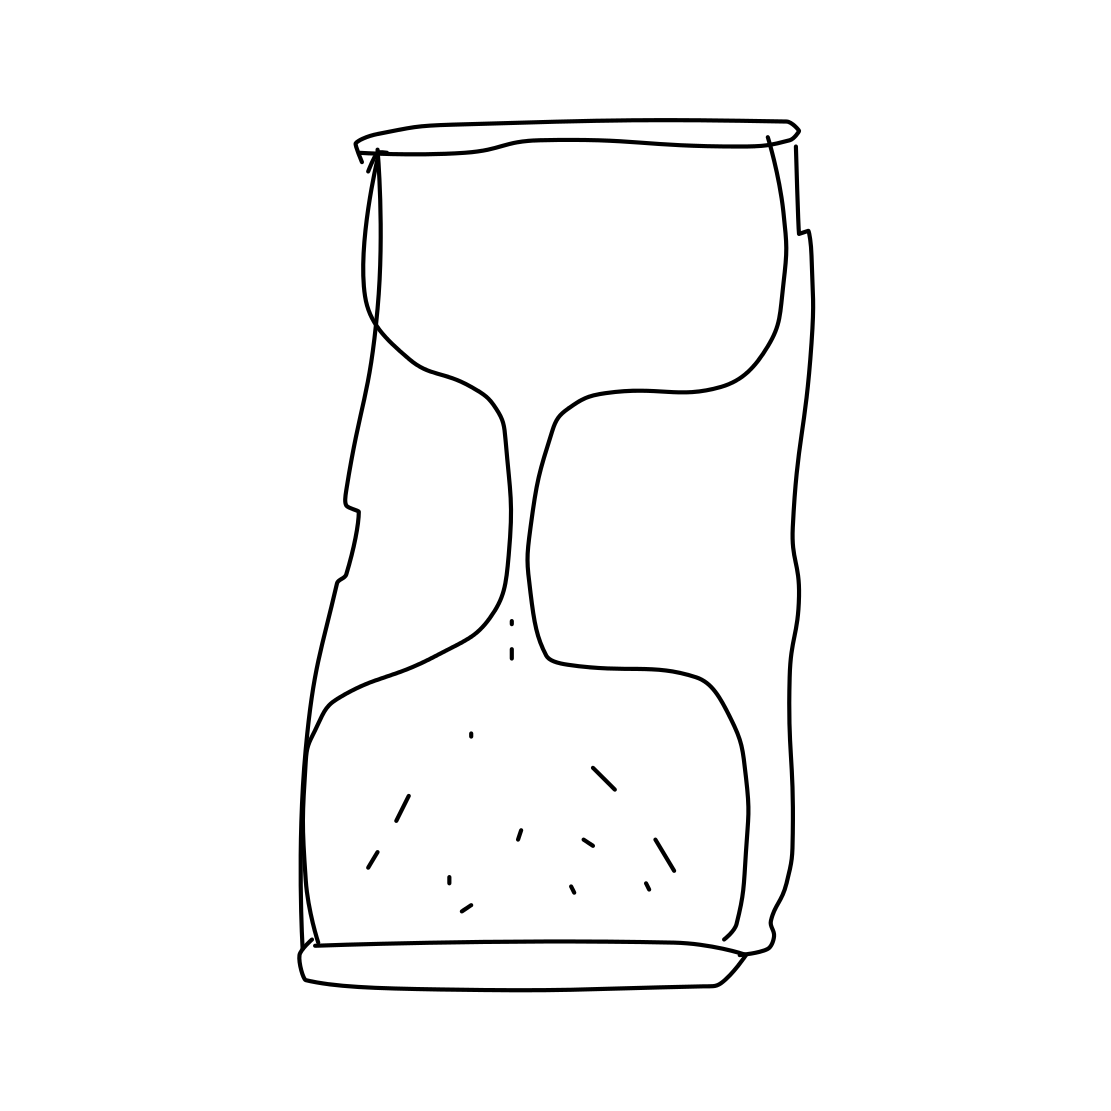Is there a sketchy teacup in the picture? No 